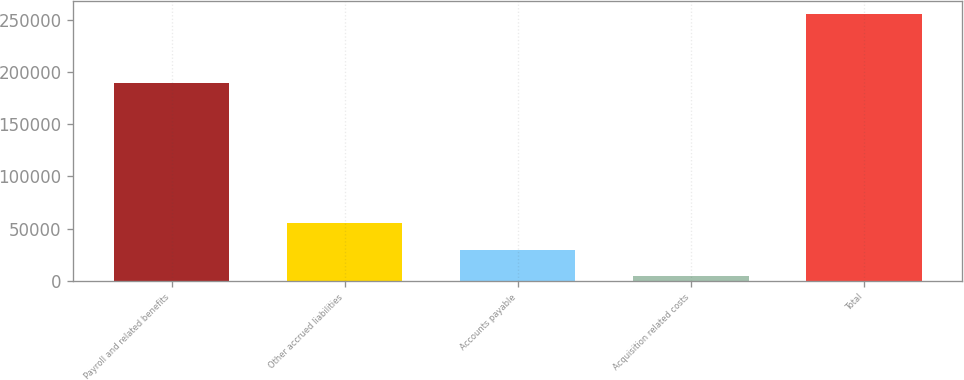Convert chart to OTSL. <chart><loc_0><loc_0><loc_500><loc_500><bar_chart><fcel>Payroll and related benefits<fcel>Other accrued liabilities<fcel>Accounts payable<fcel>Acquisition related costs<fcel>Total<nl><fcel>189719<fcel>54993.4<fcel>29980.7<fcel>4968<fcel>255095<nl></chart> 